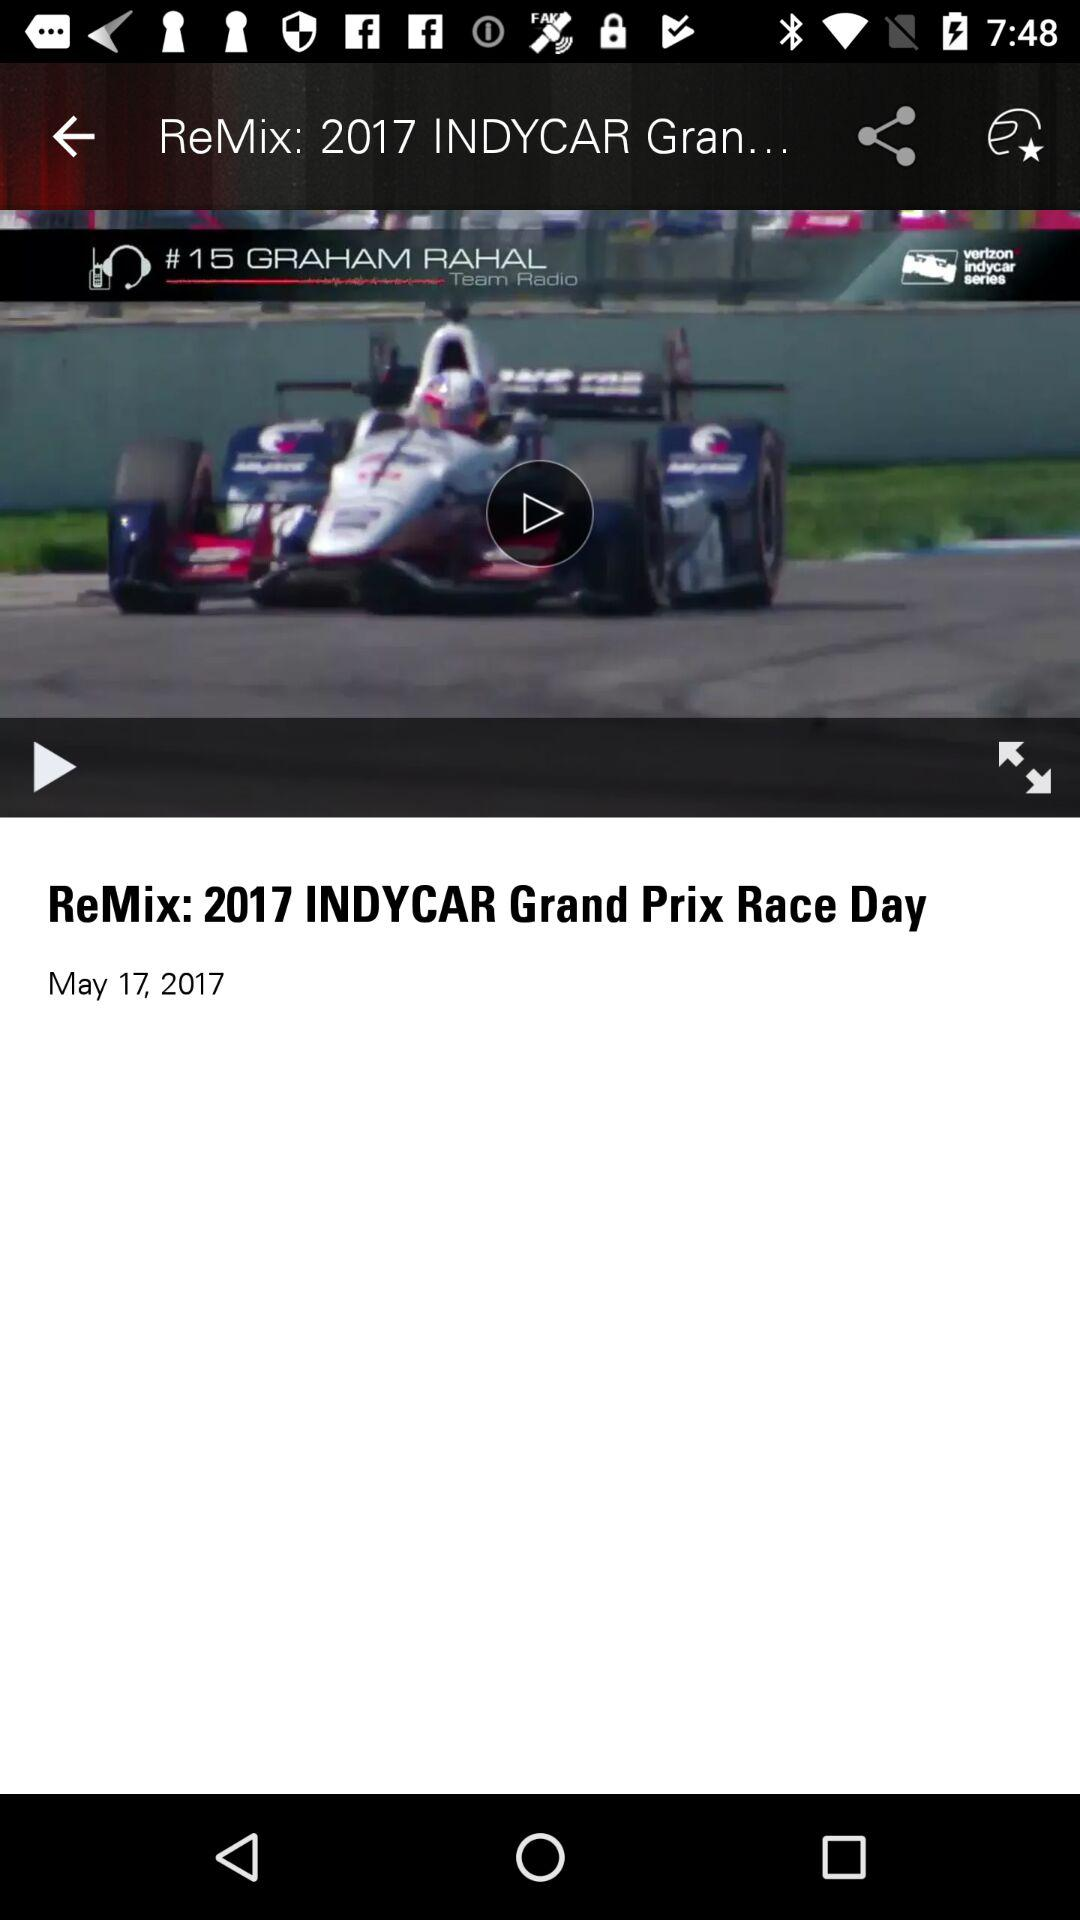What is the mentioned date? The mentioned date is May 17, 2017. 